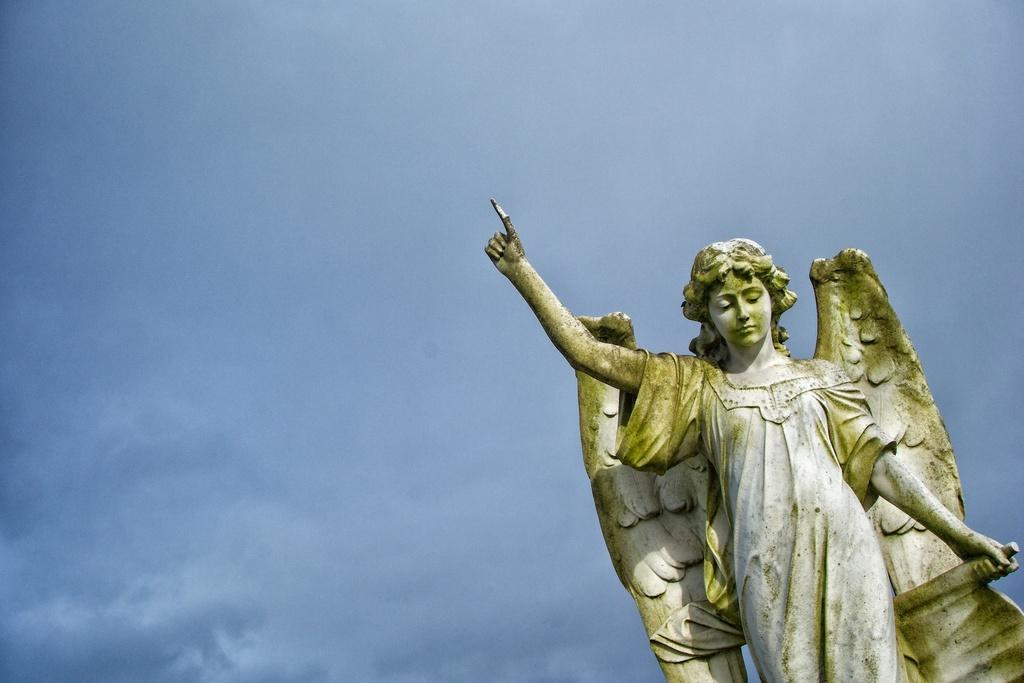What is the main subject of the image? The main subject of the image is a statue of a person. What colors are used for the statue? The statue is in ash and green color. What can be seen in the background of the image? The blue sky is visible in the background of the image. How many teeth can be seen on the statue in the image? There are no teeth visible on the statue in the image, as it is a statue and not a living being. 